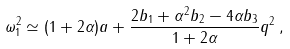Convert formula to latex. <formula><loc_0><loc_0><loc_500><loc_500>\omega _ { 1 } ^ { 2 } \simeq ( 1 + 2 \alpha ) a + \frac { 2 b _ { 1 } + \alpha ^ { 2 } b _ { 2 } - 4 \alpha b _ { 3 } } { 1 + 2 \alpha } q ^ { 2 } \, ,</formula> 